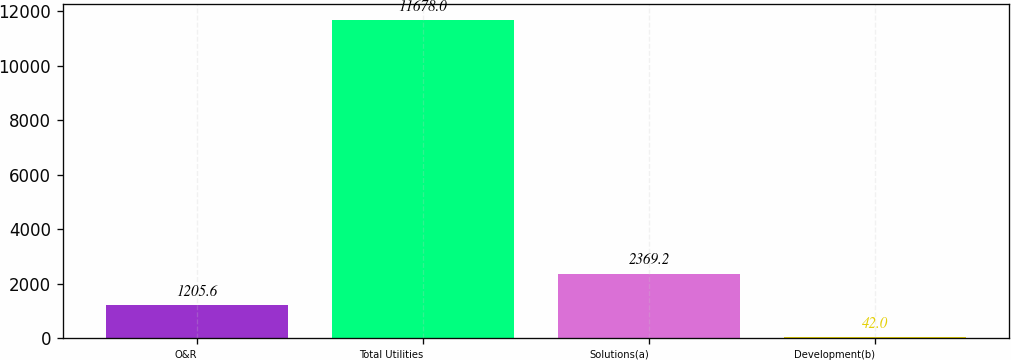Convert chart. <chart><loc_0><loc_0><loc_500><loc_500><bar_chart><fcel>O&R<fcel>Total Utilities<fcel>Solutions(a)<fcel>Development(b)<nl><fcel>1205.6<fcel>11678<fcel>2369.2<fcel>42<nl></chart> 